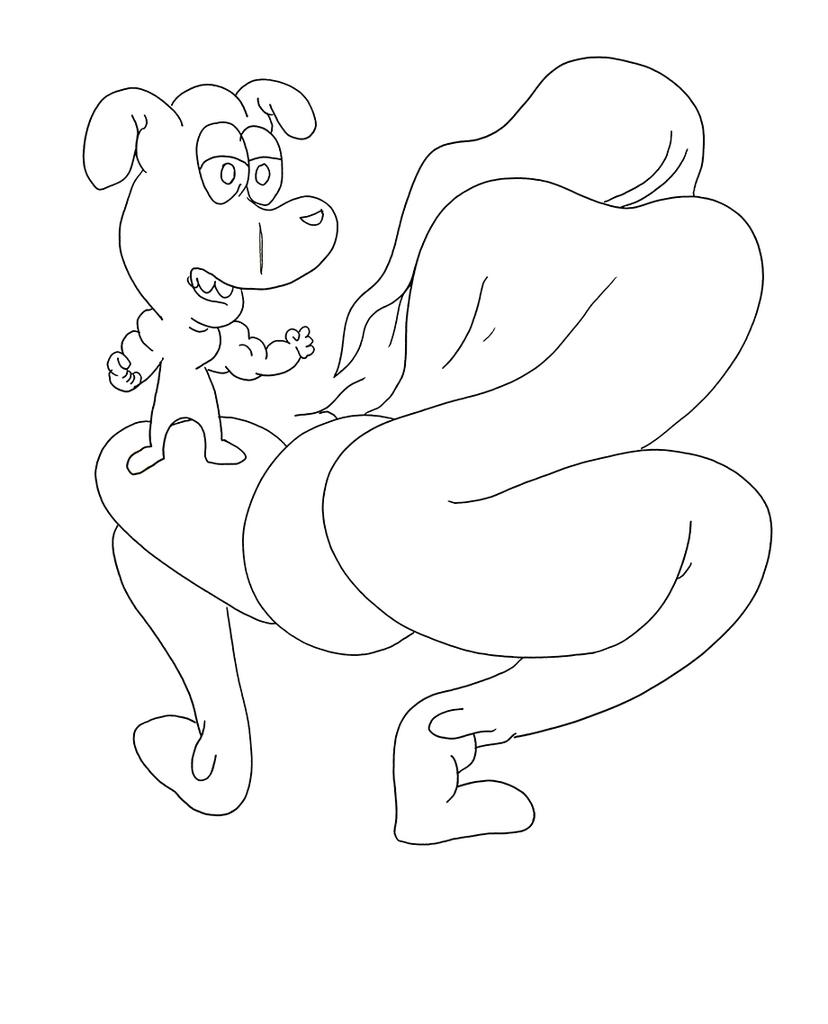What is depicted in the image? There is a sketch of a cartoon in the image. Can you describe the sketch in more detail? There is a sketch of an object that appears to be a person in the image. What type of advertisement is being displayed in the image? There is no advertisement present in the image; it only contains a sketch of a cartoon and a person. What knowledge can be gained from the image? The image itself does not convey any specific knowledge, as it is a sketch of a cartoon and a person. 